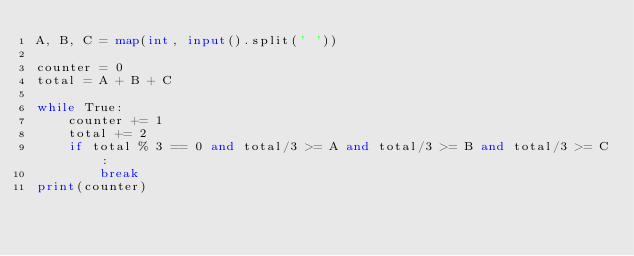<code> <loc_0><loc_0><loc_500><loc_500><_Python_>A, B, C = map(int, input().split(' '))

counter = 0
total = A + B + C

while True:
    counter += 1
    total += 2
    if total % 3 == 0 and total/3 >= A and total/3 >= B and total/3 >= C:
        break
print(counter)</code> 